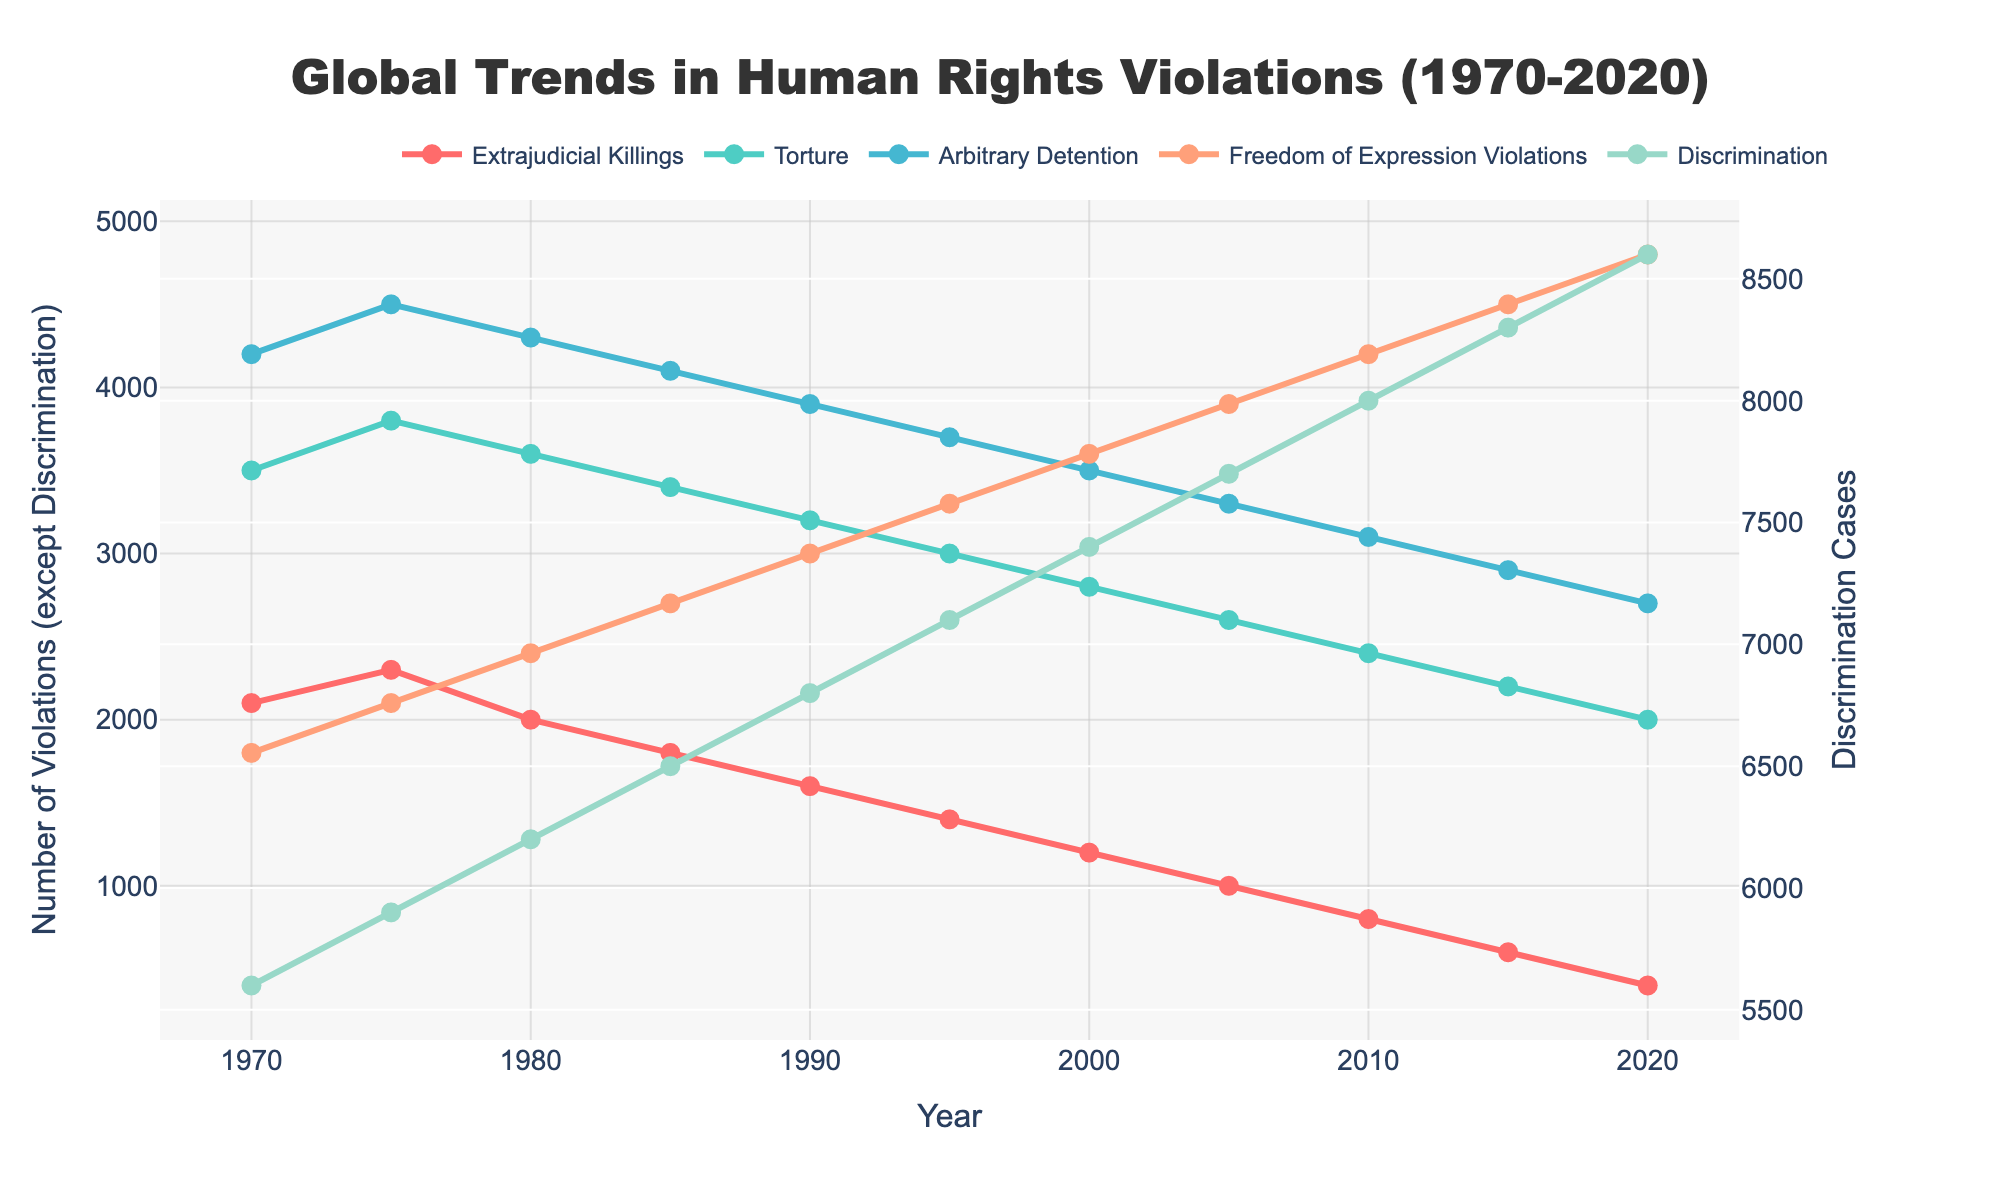Which type of violation experienced the greatest decline from 1970 to 2020? To find the greatest decline, look at the initial and final values for each category in the year 1970 and 2020. The largest difference will indicate the greatest decline. Extrajudicial Killings dropped from 2100 to 400 (decline of 1700), Torture from 3500 to 2000 (decline of 1500), Arbitrary Detention from 4200 to 2700 (decline of 1500), Freedom of Expression Violations from 1800 to 4800 (an increase), and Discrimination from 5600 to 8600 (an increase).
Answer: Extrajudicial Killings Which category saw an increase in violations from 1970 to 2020? Compare initial and final values for each category. Discrimination increased from 5600 to 8600 and Freedom of Expression Violations increased from 1800 to 4800. All other categories show a decline.
Answer: Discrimination and Freedom of Expression Violations What is the trend in Torture cases over the 50 years? Observe the trend of the blue line representing Torture cases. It starts at 3500 in 1970 and declines steadily to 2000 in 2020.
Answer: Declining In which year did Extrajudicial Killings and Arbitrary Detention both hit their lowest reported values? Look for the year where both categories have their minimum values. Extrajudicial Killings hit 400 in 2020 and Arbitrary Detention hits 2700 also in 2020.
Answer: 2020 What is the general trend in Freedom of Expression Violations from 1970 to 2020? Examine the trend of the red line representing Freedom of Expression Violations. It starts at 1800 in 1970 and rises steadily to 4800 in 2020.
Answer: Increasing By how much did the number of Extrajudicial Killings decrease between 1970 and 1980? Calculate the difference between the values in 1970 and 1980 for Extrajudicial Killings. Initial value is 2100 and final value is 2000. Difference = 2100 - 2000 = 100.
Answer: 100 What is the range of values for Discrimination across the given years? The range is found by subtracting the lowest value from the highest value for Discrimination. Highest value is 8600 in 2020 and lowest is 5600 in 1970. Range = 8600 - 5600 = 3000.
Answer: 3000 Which violation type shows the most variability in its trend over the 50 years? Assess each line for its variability. Although several patterns are decreasing, the trend line for Freedom of Expression Violations shows an increasing pattern, implying more variability.
Answer: Freedom of Expression Violations What happens to the number of Torture cases between 2010 and 2020? Examine the trend of the blue line for Torture cases between these years. It goes from 2400 in 2010 to 2000 in 2020.
Answer: Decreases Which category consistently saw more than 3000 cases from 1970 to 2020? Look for lines that always stay above the 3000 mark in the figure. Discrimination consistently has cases more than 3000 throughout this period.
Answer: Discrimination 